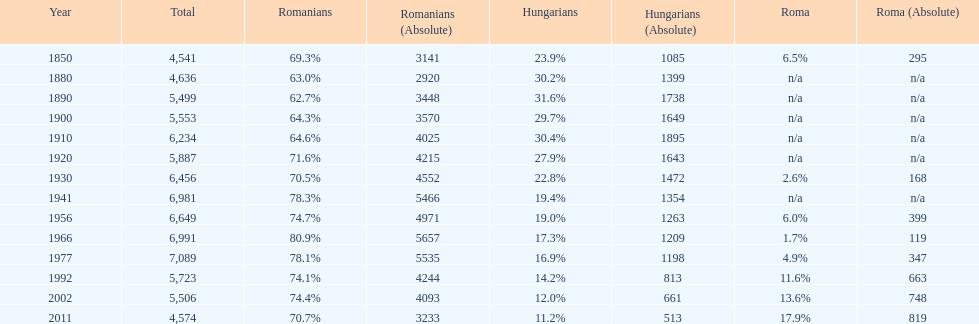What is the number of hungarians in 1850? 23.9%. 